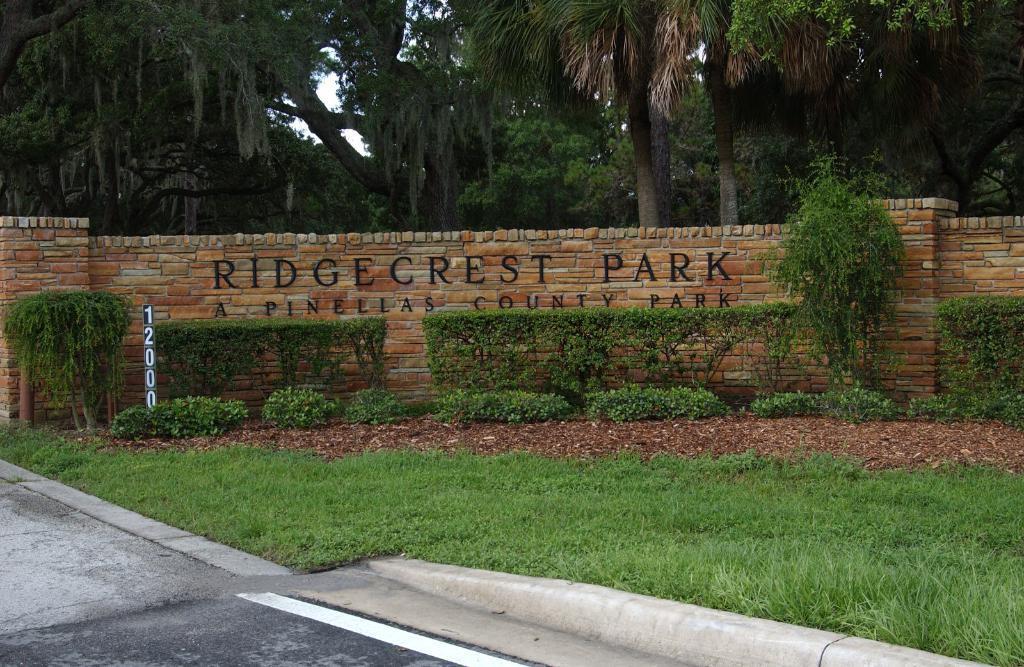How would you summarize this image in a sentence or two? In the center of the image we can see a wall, bushes, board, dry leaves, grass. In the background of the image we can see the trees. At the bottom of the image we can see the road. 